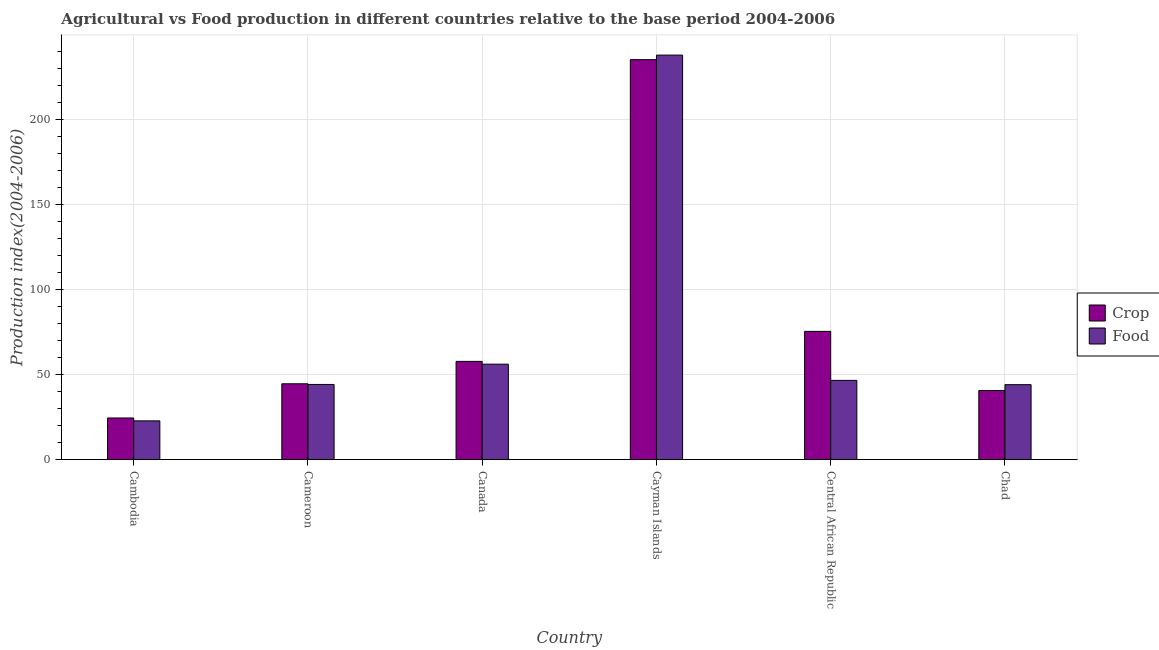How many different coloured bars are there?
Your response must be concise. 2. Are the number of bars per tick equal to the number of legend labels?
Ensure brevity in your answer.  Yes. Are the number of bars on each tick of the X-axis equal?
Ensure brevity in your answer.  Yes. How many bars are there on the 3rd tick from the right?
Your response must be concise. 2. What is the label of the 4th group of bars from the left?
Make the answer very short. Cayman Islands. What is the crop production index in Canada?
Provide a succinct answer. 57.85. Across all countries, what is the maximum food production index?
Provide a succinct answer. 238.05. Across all countries, what is the minimum food production index?
Give a very brief answer. 22.85. In which country was the crop production index maximum?
Give a very brief answer. Cayman Islands. In which country was the crop production index minimum?
Your answer should be very brief. Cambodia. What is the total food production index in the graph?
Offer a terse response. 452.21. What is the difference between the crop production index in Canada and that in Chad?
Keep it short and to the point. 17.14. What is the difference between the food production index in Cambodia and the crop production index in Chad?
Your answer should be very brief. -17.86. What is the average crop production index per country?
Provide a short and direct response. 79.77. What is the difference between the food production index and crop production index in Cameroon?
Offer a terse response. -0.38. What is the ratio of the crop production index in Cayman Islands to that in Chad?
Keep it short and to the point. 5.78. Is the crop production index in Central African Republic less than that in Chad?
Give a very brief answer. No. Is the difference between the food production index in Canada and Central African Republic greater than the difference between the crop production index in Canada and Central African Republic?
Ensure brevity in your answer.  Yes. What is the difference between the highest and the second highest crop production index?
Your answer should be very brief. 159.88. What is the difference between the highest and the lowest crop production index?
Offer a very short reply. 210.83. What does the 2nd bar from the left in Cayman Islands represents?
Provide a short and direct response. Food. What does the 1st bar from the right in Cameroon represents?
Offer a terse response. Food. Are all the bars in the graph horizontal?
Your answer should be compact. No. How many countries are there in the graph?
Keep it short and to the point. 6. What is the difference between two consecutive major ticks on the Y-axis?
Make the answer very short. 50. Does the graph contain any zero values?
Make the answer very short. No. Does the graph contain grids?
Provide a short and direct response. Yes. Where does the legend appear in the graph?
Your answer should be compact. Center right. How many legend labels are there?
Your answer should be compact. 2. How are the legend labels stacked?
Provide a succinct answer. Vertical. What is the title of the graph?
Your response must be concise. Agricultural vs Food production in different countries relative to the base period 2004-2006. What is the label or title of the X-axis?
Provide a short and direct response. Country. What is the label or title of the Y-axis?
Give a very brief answer. Production index(2004-2006). What is the Production index(2004-2006) in Crop in Cambodia?
Provide a short and direct response. 24.55. What is the Production index(2004-2006) in Food in Cambodia?
Offer a very short reply. 22.85. What is the Production index(2004-2006) of Crop in Cameroon?
Ensure brevity in your answer.  44.66. What is the Production index(2004-2006) of Food in Cameroon?
Keep it short and to the point. 44.28. What is the Production index(2004-2006) in Crop in Canada?
Provide a succinct answer. 57.85. What is the Production index(2004-2006) of Food in Canada?
Give a very brief answer. 56.21. What is the Production index(2004-2006) in Crop in Cayman Islands?
Provide a short and direct response. 235.38. What is the Production index(2004-2006) in Food in Cayman Islands?
Offer a terse response. 238.05. What is the Production index(2004-2006) of Crop in Central African Republic?
Offer a very short reply. 75.5. What is the Production index(2004-2006) of Food in Central African Republic?
Provide a succinct answer. 46.67. What is the Production index(2004-2006) of Crop in Chad?
Ensure brevity in your answer.  40.71. What is the Production index(2004-2006) in Food in Chad?
Provide a succinct answer. 44.15. Across all countries, what is the maximum Production index(2004-2006) in Crop?
Your answer should be compact. 235.38. Across all countries, what is the maximum Production index(2004-2006) of Food?
Your answer should be compact. 238.05. Across all countries, what is the minimum Production index(2004-2006) in Crop?
Provide a short and direct response. 24.55. Across all countries, what is the minimum Production index(2004-2006) in Food?
Your answer should be compact. 22.85. What is the total Production index(2004-2006) in Crop in the graph?
Keep it short and to the point. 478.65. What is the total Production index(2004-2006) of Food in the graph?
Your answer should be compact. 452.21. What is the difference between the Production index(2004-2006) of Crop in Cambodia and that in Cameroon?
Offer a very short reply. -20.11. What is the difference between the Production index(2004-2006) in Food in Cambodia and that in Cameroon?
Ensure brevity in your answer.  -21.43. What is the difference between the Production index(2004-2006) of Crop in Cambodia and that in Canada?
Your response must be concise. -33.3. What is the difference between the Production index(2004-2006) in Food in Cambodia and that in Canada?
Offer a very short reply. -33.36. What is the difference between the Production index(2004-2006) of Crop in Cambodia and that in Cayman Islands?
Give a very brief answer. -210.83. What is the difference between the Production index(2004-2006) in Food in Cambodia and that in Cayman Islands?
Offer a very short reply. -215.2. What is the difference between the Production index(2004-2006) of Crop in Cambodia and that in Central African Republic?
Provide a succinct answer. -50.95. What is the difference between the Production index(2004-2006) of Food in Cambodia and that in Central African Republic?
Your response must be concise. -23.82. What is the difference between the Production index(2004-2006) of Crop in Cambodia and that in Chad?
Your answer should be compact. -16.16. What is the difference between the Production index(2004-2006) in Food in Cambodia and that in Chad?
Make the answer very short. -21.3. What is the difference between the Production index(2004-2006) in Crop in Cameroon and that in Canada?
Give a very brief answer. -13.19. What is the difference between the Production index(2004-2006) in Food in Cameroon and that in Canada?
Offer a very short reply. -11.93. What is the difference between the Production index(2004-2006) of Crop in Cameroon and that in Cayman Islands?
Keep it short and to the point. -190.72. What is the difference between the Production index(2004-2006) of Food in Cameroon and that in Cayman Islands?
Offer a very short reply. -193.77. What is the difference between the Production index(2004-2006) of Crop in Cameroon and that in Central African Republic?
Your response must be concise. -30.84. What is the difference between the Production index(2004-2006) of Food in Cameroon and that in Central African Republic?
Your response must be concise. -2.39. What is the difference between the Production index(2004-2006) in Crop in Cameroon and that in Chad?
Keep it short and to the point. 3.95. What is the difference between the Production index(2004-2006) of Food in Cameroon and that in Chad?
Your answer should be very brief. 0.13. What is the difference between the Production index(2004-2006) of Crop in Canada and that in Cayman Islands?
Keep it short and to the point. -177.53. What is the difference between the Production index(2004-2006) of Food in Canada and that in Cayman Islands?
Offer a terse response. -181.84. What is the difference between the Production index(2004-2006) in Crop in Canada and that in Central African Republic?
Your answer should be very brief. -17.65. What is the difference between the Production index(2004-2006) of Food in Canada and that in Central African Republic?
Provide a short and direct response. 9.54. What is the difference between the Production index(2004-2006) in Crop in Canada and that in Chad?
Provide a short and direct response. 17.14. What is the difference between the Production index(2004-2006) in Food in Canada and that in Chad?
Offer a very short reply. 12.06. What is the difference between the Production index(2004-2006) of Crop in Cayman Islands and that in Central African Republic?
Keep it short and to the point. 159.88. What is the difference between the Production index(2004-2006) in Food in Cayman Islands and that in Central African Republic?
Offer a terse response. 191.38. What is the difference between the Production index(2004-2006) of Crop in Cayman Islands and that in Chad?
Your answer should be compact. 194.67. What is the difference between the Production index(2004-2006) of Food in Cayman Islands and that in Chad?
Provide a succinct answer. 193.9. What is the difference between the Production index(2004-2006) in Crop in Central African Republic and that in Chad?
Your answer should be very brief. 34.79. What is the difference between the Production index(2004-2006) in Food in Central African Republic and that in Chad?
Offer a terse response. 2.52. What is the difference between the Production index(2004-2006) of Crop in Cambodia and the Production index(2004-2006) of Food in Cameroon?
Your answer should be compact. -19.73. What is the difference between the Production index(2004-2006) in Crop in Cambodia and the Production index(2004-2006) in Food in Canada?
Make the answer very short. -31.66. What is the difference between the Production index(2004-2006) of Crop in Cambodia and the Production index(2004-2006) of Food in Cayman Islands?
Ensure brevity in your answer.  -213.5. What is the difference between the Production index(2004-2006) in Crop in Cambodia and the Production index(2004-2006) in Food in Central African Republic?
Your answer should be very brief. -22.12. What is the difference between the Production index(2004-2006) in Crop in Cambodia and the Production index(2004-2006) in Food in Chad?
Provide a succinct answer. -19.6. What is the difference between the Production index(2004-2006) of Crop in Cameroon and the Production index(2004-2006) of Food in Canada?
Offer a very short reply. -11.55. What is the difference between the Production index(2004-2006) in Crop in Cameroon and the Production index(2004-2006) in Food in Cayman Islands?
Your answer should be compact. -193.39. What is the difference between the Production index(2004-2006) in Crop in Cameroon and the Production index(2004-2006) in Food in Central African Republic?
Provide a short and direct response. -2.01. What is the difference between the Production index(2004-2006) in Crop in Cameroon and the Production index(2004-2006) in Food in Chad?
Your answer should be compact. 0.51. What is the difference between the Production index(2004-2006) in Crop in Canada and the Production index(2004-2006) in Food in Cayman Islands?
Offer a terse response. -180.2. What is the difference between the Production index(2004-2006) of Crop in Canada and the Production index(2004-2006) of Food in Central African Republic?
Keep it short and to the point. 11.18. What is the difference between the Production index(2004-2006) of Crop in Canada and the Production index(2004-2006) of Food in Chad?
Give a very brief answer. 13.7. What is the difference between the Production index(2004-2006) of Crop in Cayman Islands and the Production index(2004-2006) of Food in Central African Republic?
Offer a very short reply. 188.71. What is the difference between the Production index(2004-2006) in Crop in Cayman Islands and the Production index(2004-2006) in Food in Chad?
Give a very brief answer. 191.23. What is the difference between the Production index(2004-2006) of Crop in Central African Republic and the Production index(2004-2006) of Food in Chad?
Offer a very short reply. 31.35. What is the average Production index(2004-2006) of Crop per country?
Offer a terse response. 79.78. What is the average Production index(2004-2006) in Food per country?
Your answer should be compact. 75.37. What is the difference between the Production index(2004-2006) in Crop and Production index(2004-2006) in Food in Cambodia?
Make the answer very short. 1.7. What is the difference between the Production index(2004-2006) in Crop and Production index(2004-2006) in Food in Cameroon?
Your answer should be compact. 0.38. What is the difference between the Production index(2004-2006) in Crop and Production index(2004-2006) in Food in Canada?
Provide a short and direct response. 1.64. What is the difference between the Production index(2004-2006) of Crop and Production index(2004-2006) of Food in Cayman Islands?
Provide a succinct answer. -2.67. What is the difference between the Production index(2004-2006) of Crop and Production index(2004-2006) of Food in Central African Republic?
Your answer should be very brief. 28.83. What is the difference between the Production index(2004-2006) in Crop and Production index(2004-2006) in Food in Chad?
Your response must be concise. -3.44. What is the ratio of the Production index(2004-2006) of Crop in Cambodia to that in Cameroon?
Provide a short and direct response. 0.55. What is the ratio of the Production index(2004-2006) in Food in Cambodia to that in Cameroon?
Provide a succinct answer. 0.52. What is the ratio of the Production index(2004-2006) of Crop in Cambodia to that in Canada?
Your response must be concise. 0.42. What is the ratio of the Production index(2004-2006) in Food in Cambodia to that in Canada?
Provide a succinct answer. 0.41. What is the ratio of the Production index(2004-2006) in Crop in Cambodia to that in Cayman Islands?
Your answer should be very brief. 0.1. What is the ratio of the Production index(2004-2006) of Food in Cambodia to that in Cayman Islands?
Give a very brief answer. 0.1. What is the ratio of the Production index(2004-2006) of Crop in Cambodia to that in Central African Republic?
Give a very brief answer. 0.33. What is the ratio of the Production index(2004-2006) of Food in Cambodia to that in Central African Republic?
Your answer should be compact. 0.49. What is the ratio of the Production index(2004-2006) in Crop in Cambodia to that in Chad?
Make the answer very short. 0.6. What is the ratio of the Production index(2004-2006) of Food in Cambodia to that in Chad?
Keep it short and to the point. 0.52. What is the ratio of the Production index(2004-2006) in Crop in Cameroon to that in Canada?
Give a very brief answer. 0.77. What is the ratio of the Production index(2004-2006) of Food in Cameroon to that in Canada?
Give a very brief answer. 0.79. What is the ratio of the Production index(2004-2006) of Crop in Cameroon to that in Cayman Islands?
Offer a terse response. 0.19. What is the ratio of the Production index(2004-2006) of Food in Cameroon to that in Cayman Islands?
Provide a succinct answer. 0.19. What is the ratio of the Production index(2004-2006) in Crop in Cameroon to that in Central African Republic?
Give a very brief answer. 0.59. What is the ratio of the Production index(2004-2006) in Food in Cameroon to that in Central African Republic?
Provide a short and direct response. 0.95. What is the ratio of the Production index(2004-2006) of Crop in Cameroon to that in Chad?
Keep it short and to the point. 1.1. What is the ratio of the Production index(2004-2006) in Food in Cameroon to that in Chad?
Offer a very short reply. 1. What is the ratio of the Production index(2004-2006) in Crop in Canada to that in Cayman Islands?
Ensure brevity in your answer.  0.25. What is the ratio of the Production index(2004-2006) in Food in Canada to that in Cayman Islands?
Provide a succinct answer. 0.24. What is the ratio of the Production index(2004-2006) of Crop in Canada to that in Central African Republic?
Give a very brief answer. 0.77. What is the ratio of the Production index(2004-2006) in Food in Canada to that in Central African Republic?
Provide a short and direct response. 1.2. What is the ratio of the Production index(2004-2006) in Crop in Canada to that in Chad?
Your response must be concise. 1.42. What is the ratio of the Production index(2004-2006) of Food in Canada to that in Chad?
Offer a terse response. 1.27. What is the ratio of the Production index(2004-2006) in Crop in Cayman Islands to that in Central African Republic?
Offer a terse response. 3.12. What is the ratio of the Production index(2004-2006) in Food in Cayman Islands to that in Central African Republic?
Ensure brevity in your answer.  5.1. What is the ratio of the Production index(2004-2006) of Crop in Cayman Islands to that in Chad?
Provide a short and direct response. 5.78. What is the ratio of the Production index(2004-2006) of Food in Cayman Islands to that in Chad?
Your answer should be very brief. 5.39. What is the ratio of the Production index(2004-2006) in Crop in Central African Republic to that in Chad?
Keep it short and to the point. 1.85. What is the ratio of the Production index(2004-2006) in Food in Central African Republic to that in Chad?
Offer a terse response. 1.06. What is the difference between the highest and the second highest Production index(2004-2006) in Crop?
Make the answer very short. 159.88. What is the difference between the highest and the second highest Production index(2004-2006) in Food?
Your answer should be compact. 181.84. What is the difference between the highest and the lowest Production index(2004-2006) in Crop?
Make the answer very short. 210.83. What is the difference between the highest and the lowest Production index(2004-2006) in Food?
Your answer should be compact. 215.2. 